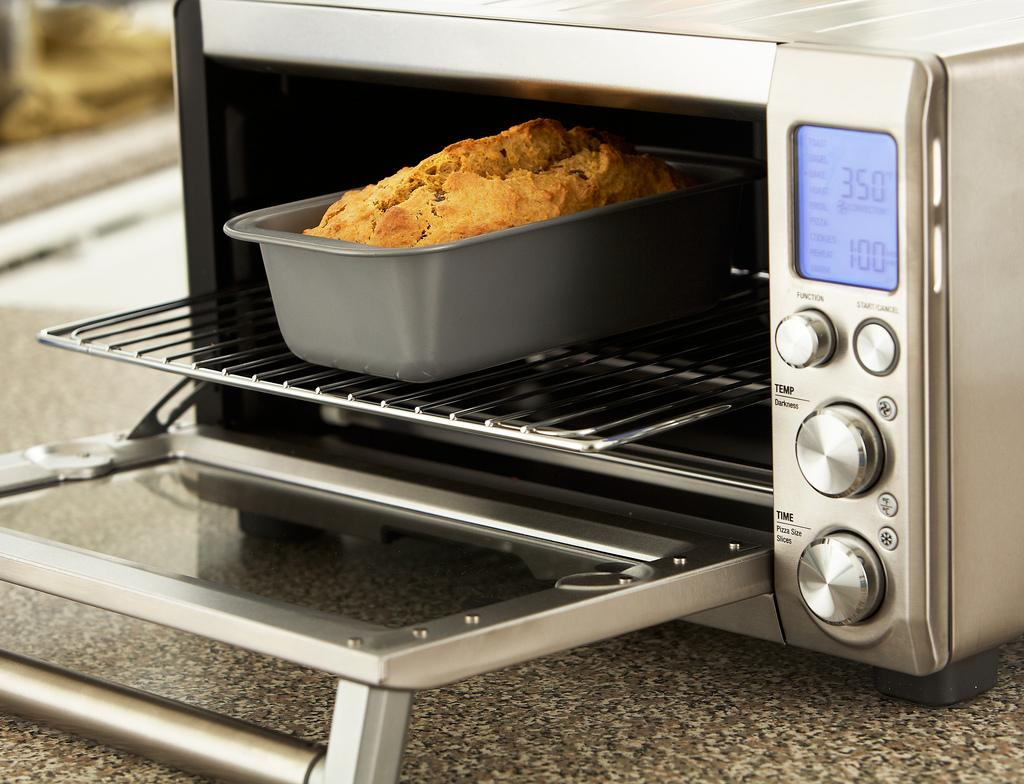<image>
Describe the image concisely. Conventional oven that has the temperature currently at 350. 